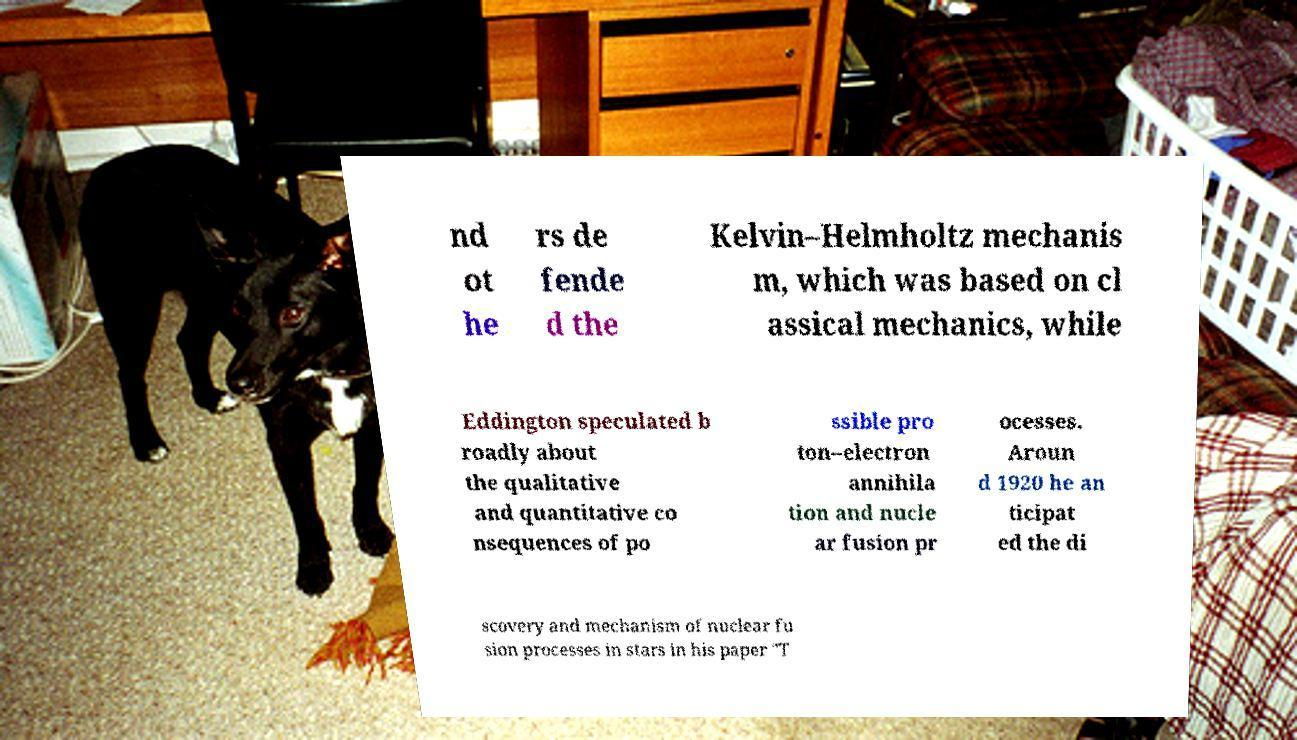I need the written content from this picture converted into text. Can you do that? nd ot he rs de fende d the Kelvin–Helmholtz mechanis m, which was based on cl assical mechanics, while Eddington speculated b roadly about the qualitative and quantitative co nsequences of po ssible pro ton–electron annihila tion and nucle ar fusion pr ocesses. Aroun d 1920 he an ticipat ed the di scovery and mechanism of nuclear fu sion processes in stars in his paper "T 